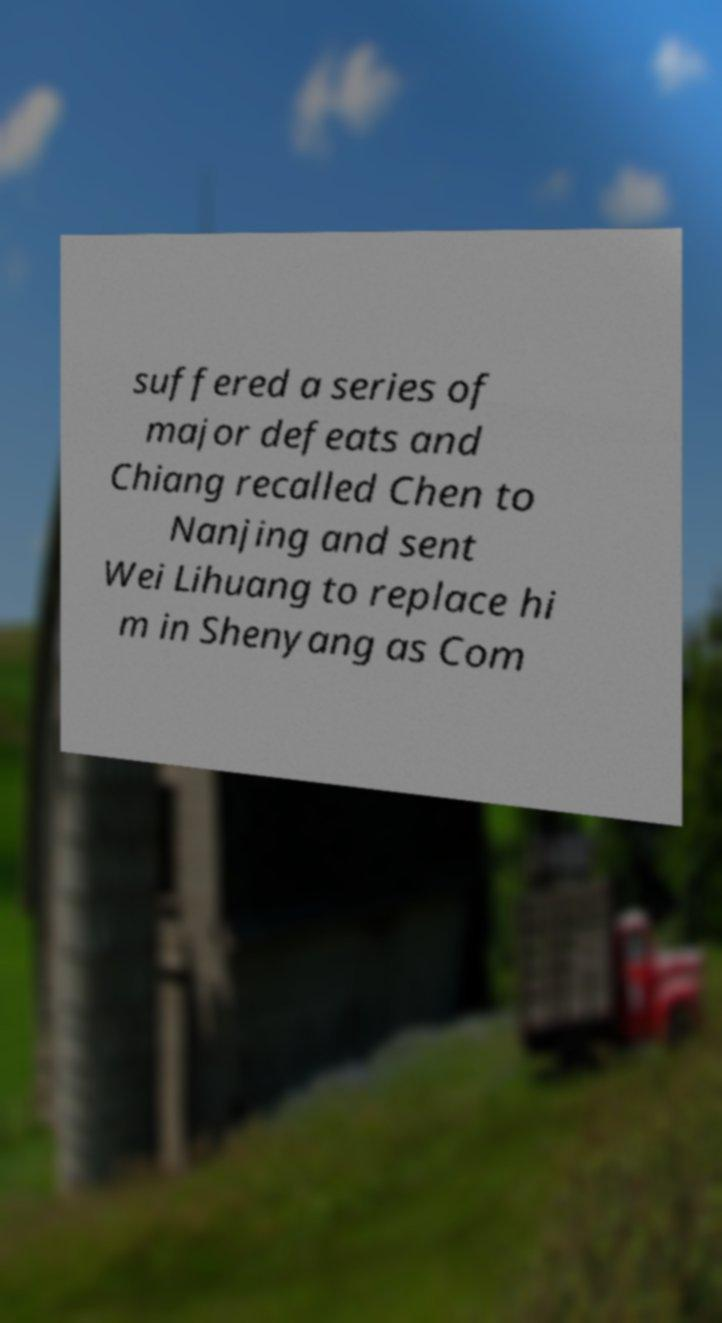I need the written content from this picture converted into text. Can you do that? suffered a series of major defeats and Chiang recalled Chen to Nanjing and sent Wei Lihuang to replace hi m in Shenyang as Com 